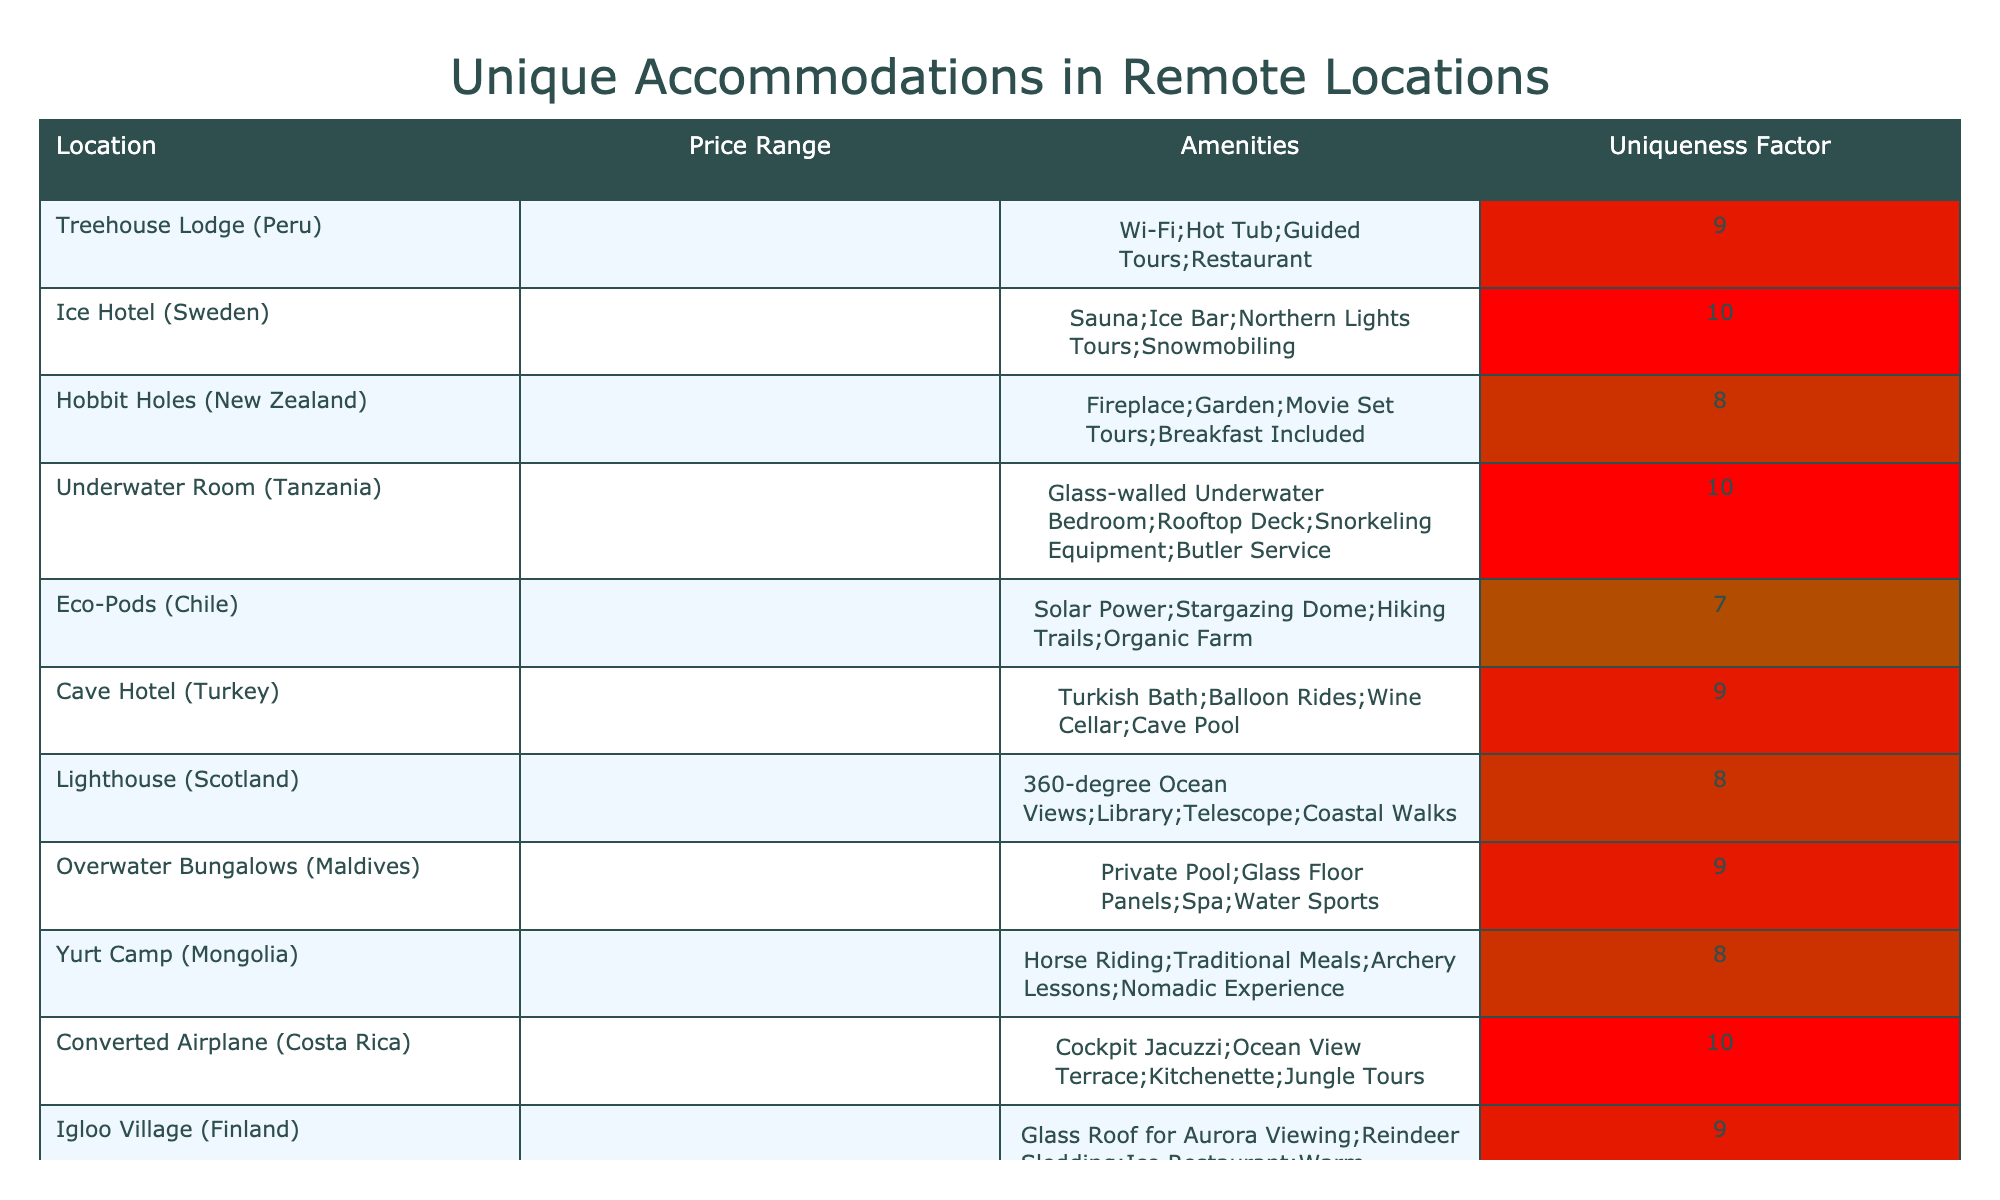What is the location with the highest uniqueness factor? The highest uniqueness factor in the table is 10. After scanning through the uniqueness factors, I see that the Ice Hotel in Sweden and the Underwater Room in Tanzania both have this factor. It can be concluded that they share the highest uniqueness.
Answer: Ice Hotel (Sweden) and Underwater Room (Tanzania) Which accommodation has a private pool? Looking at the amenities column, Overwater Bungalows in the Maldives has the amenity "Private Pool." This indicates that this accommodation offers this specific feature for guests.
Answer: Overwater Bungalows (Maldives) How many accommodations are priced at $$$? By counting the entries that fall under the $$$ price range in the table, I find that there are four such accommodations: Ice Hotel, Lighthouse, Igloo Village, and Cliff-side Pods.
Answer: 4 What is the average uniqueness factor of accommodations priced at $$? First, identify the accommodations priced at $$: Hobbit Holes, Eco-Pods, Yurt Camp, Floating Cabins, Desert Dome, and Treetop Spheres. The uniqueness factors for these are 8, 7, 8, 7, 8, and 9 respectively. Their sum is (8 + 7 + 8 + 7 + 8 + 9) = 47. Since there are 6 accommodations, the average is 47/6 = 7.83.
Answer: 7.83 Is the Converted Airplane in Costa Rica unique in its offerings? Looking at the uniqueness factor for the Converted Airplane, it has a score of 10, which indicates a high level of uniqueness according to the table's scoring system. Therefore, this accommodation can be considered unique.
Answer: Yes Which accommodation has the lowest uniqueness factor among the ones listed? By scanning the uniqueness factor column, I see that Eco-Pods in Chile have the lowest factor at 7. This indicates that among all options, this accommodation is rated comparatively lower.
Answer: Eco-Pods (Chile) Do any accommodations have both a hot tub and guided tours? Upon examining the amenities, the Treehouse Lodge in Peru has both "Hot Tub" and "Guided Tours" listed, verifying that it provides these features.
Answer: Yes Does the average uniqueness factor of accommodations with a glass roof exceed 8? The only accommodation with a glass roof is the Igloo Village in Finland, whose uniqueness factor is 9. Since this is higher than 8, the average uniqueness factor of such accommodations is greater than 8.
Answer: Yes 